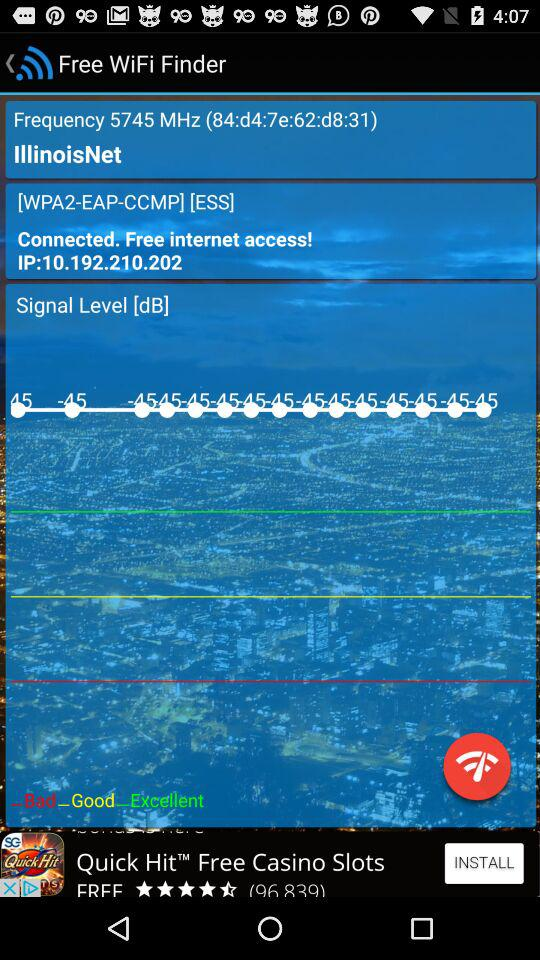What is the Signal level?
When the provided information is insufficient, respond with <no answer>. <no answer> 